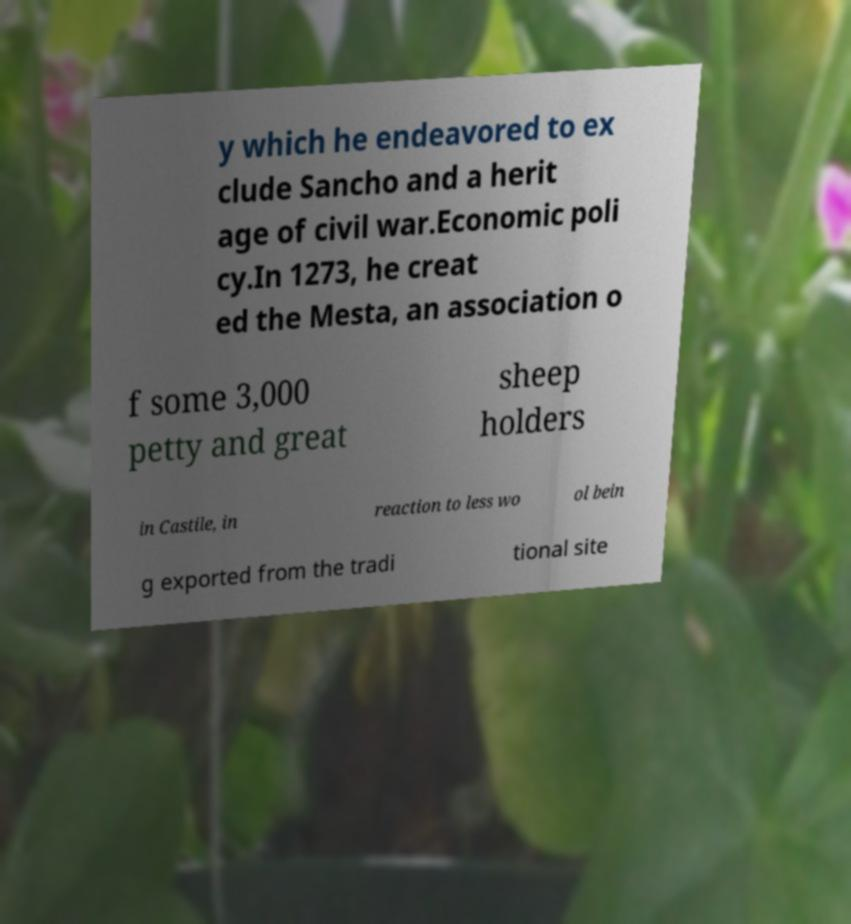Can you accurately transcribe the text from the provided image for me? y which he endeavored to ex clude Sancho and a herit age of civil war.Economic poli cy.In 1273, he creat ed the Mesta, an association o f some 3,000 petty and great sheep holders in Castile, in reaction to less wo ol bein g exported from the tradi tional site 